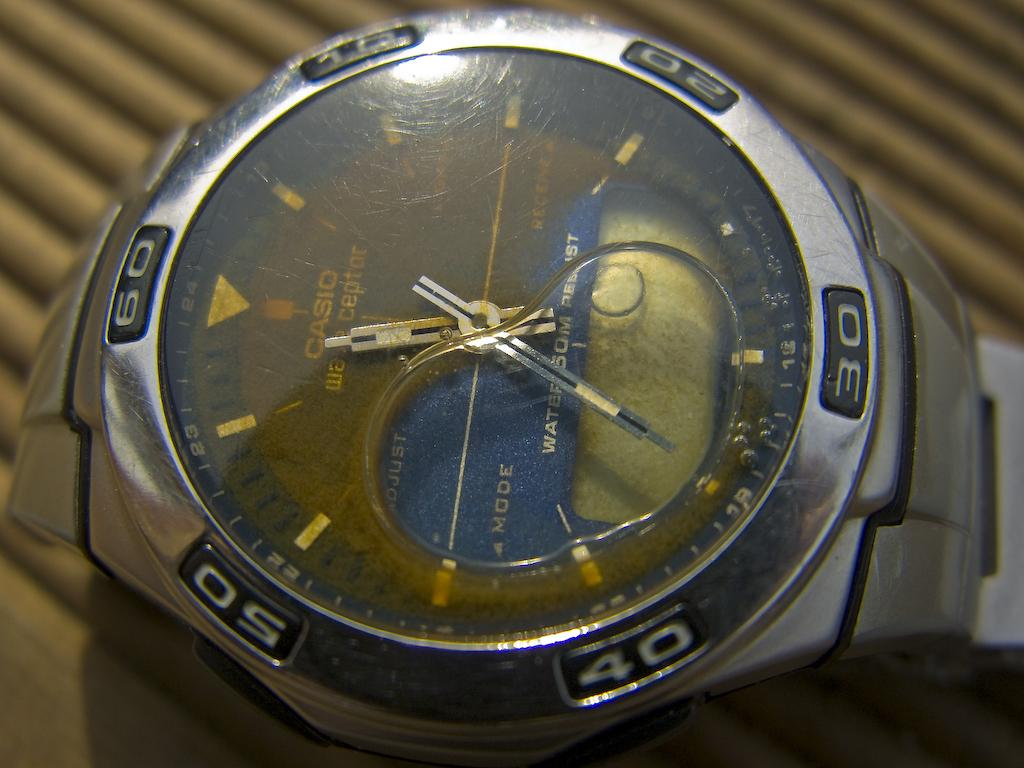<image>
Summarize the visual content of the image. A Casio Watch has water inside of the display while sitting on a wooden surface 